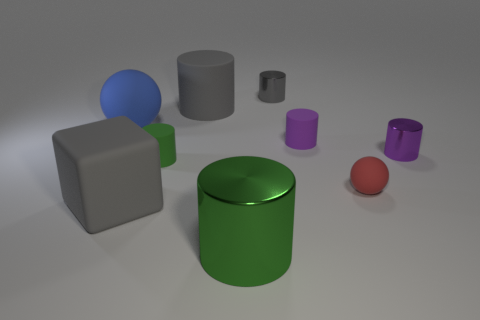Subtract all purple cylinders. How many cylinders are left? 4 Subtract 2 cylinders. How many cylinders are left? 4 Subtract all purple cylinders. How many cylinders are left? 4 Subtract all brown cylinders. Subtract all cyan balls. How many cylinders are left? 6 Add 1 cyan shiny blocks. How many objects exist? 10 Subtract all blocks. How many objects are left? 8 Add 5 matte blocks. How many matte blocks are left? 6 Add 1 cubes. How many cubes exist? 2 Subtract 0 yellow cubes. How many objects are left? 9 Subtract all green things. Subtract all large blue objects. How many objects are left? 6 